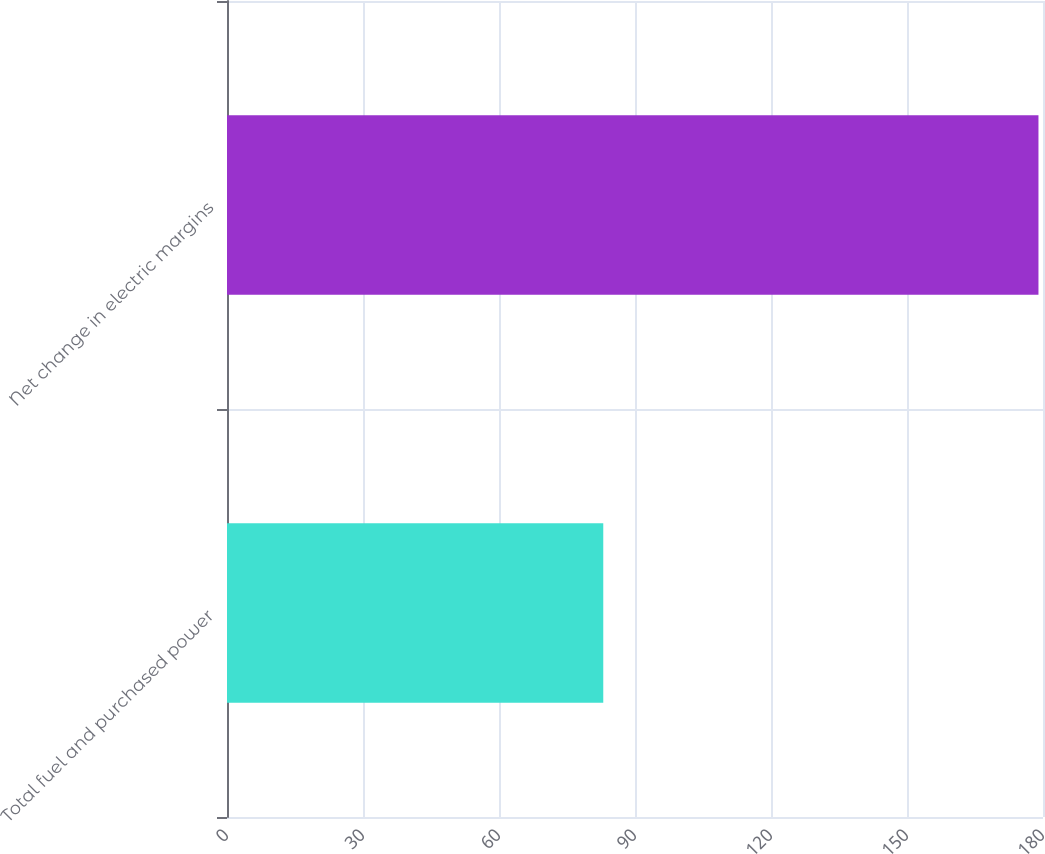<chart> <loc_0><loc_0><loc_500><loc_500><bar_chart><fcel>Total fuel and purchased power<fcel>Net change in electric margins<nl><fcel>83<fcel>179<nl></chart> 